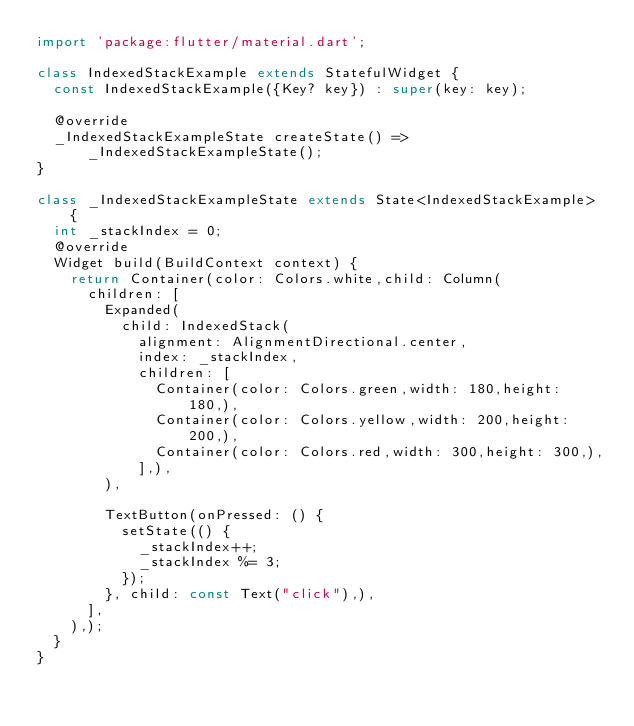<code> <loc_0><loc_0><loc_500><loc_500><_Dart_>import 'package:flutter/material.dart';

class IndexedStackExample extends StatefulWidget {
  const IndexedStackExample({Key? key}) : super(key: key);

  @override
  _IndexedStackExampleState createState() => _IndexedStackExampleState();
}

class _IndexedStackExampleState extends State<IndexedStackExample> {
  int _stackIndex = 0;
  @override
  Widget build(BuildContext context) {
    return Container(color: Colors.white,child: Column(
      children: [
        Expanded(
          child: IndexedStack(
            alignment: AlignmentDirectional.center,
            index: _stackIndex,
            children: [
              Container(color: Colors.green,width: 180,height: 180,),
              Container(color: Colors.yellow,width: 200,height: 200,),
              Container(color: Colors.red,width: 300,height: 300,),
            ],),
        ),

        TextButton(onPressed: () {
          setState(() {
            _stackIndex++;
            _stackIndex %= 3;
          });
        }, child: const Text("click"),),
      ],
    ),);
  }
}
</code> 